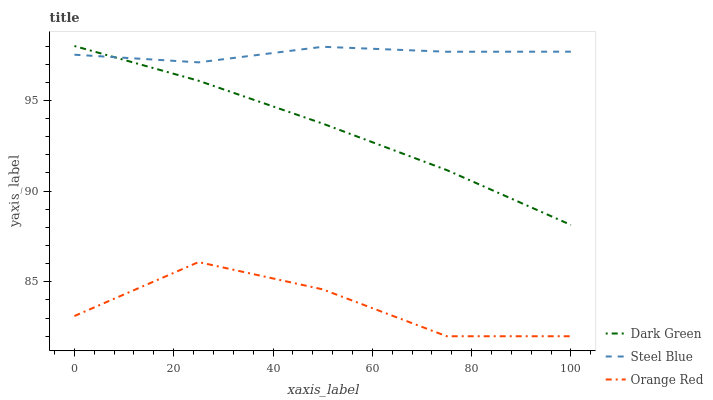Does Orange Red have the minimum area under the curve?
Answer yes or no. Yes. Does Steel Blue have the maximum area under the curve?
Answer yes or no. Yes. Does Dark Green have the minimum area under the curve?
Answer yes or no. No. Does Dark Green have the maximum area under the curve?
Answer yes or no. No. Is Dark Green the smoothest?
Answer yes or no. Yes. Is Orange Red the roughest?
Answer yes or no. Yes. Is Orange Red the smoothest?
Answer yes or no. No. Is Dark Green the roughest?
Answer yes or no. No. Does Orange Red have the lowest value?
Answer yes or no. Yes. Does Dark Green have the lowest value?
Answer yes or no. No. Does Dark Green have the highest value?
Answer yes or no. Yes. Does Orange Red have the highest value?
Answer yes or no. No. Is Orange Red less than Dark Green?
Answer yes or no. Yes. Is Dark Green greater than Orange Red?
Answer yes or no. Yes. Does Dark Green intersect Steel Blue?
Answer yes or no. Yes. Is Dark Green less than Steel Blue?
Answer yes or no. No. Is Dark Green greater than Steel Blue?
Answer yes or no. No. Does Orange Red intersect Dark Green?
Answer yes or no. No. 